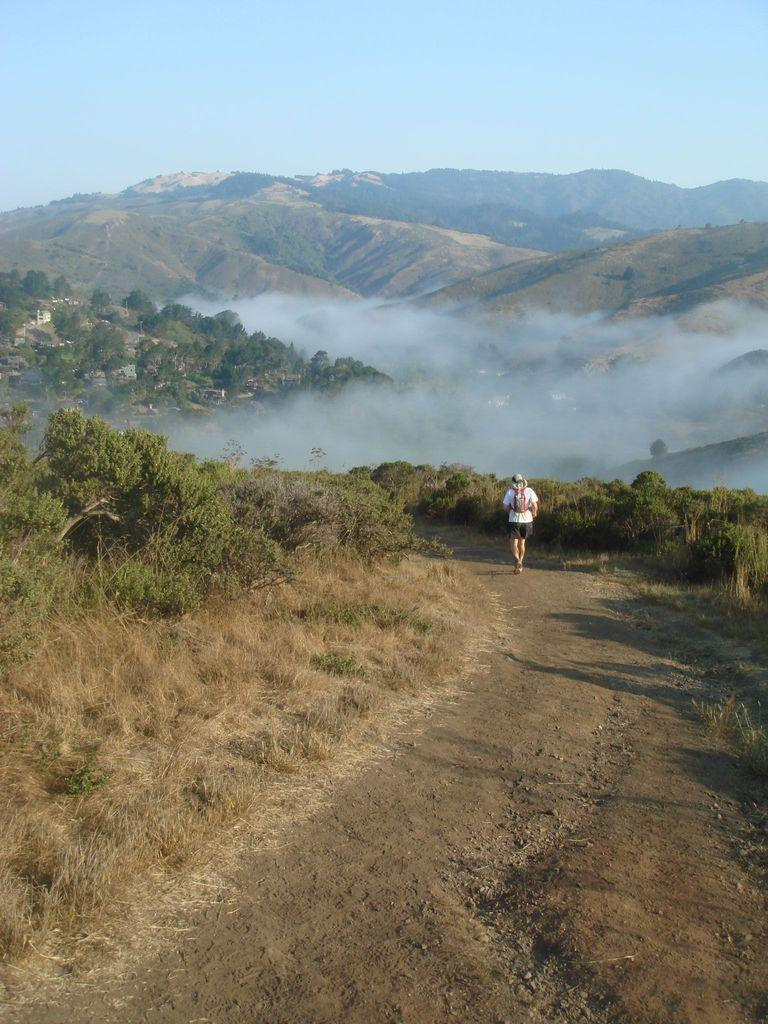What is the person in the image doing? There is a person walking in the image. What type of vegetation can be seen in the image? There are plants, grass, and trees visible in the image. What kind of landscape feature is present in the image? There are hills in the image. What is visible in the background of the image? The sky is visible in the background of the image. What type of cloth is being used to dig the ground in the image? There is no cloth or digging activity present in the image; it features a person walking in a natural landscape. 